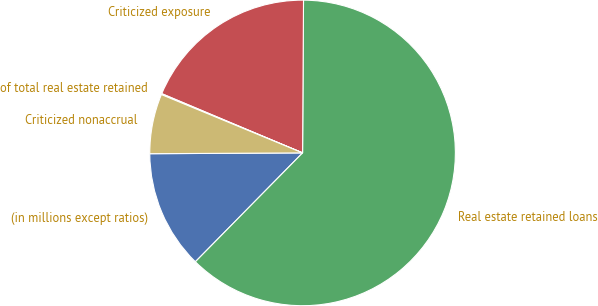Convert chart. <chart><loc_0><loc_0><loc_500><loc_500><pie_chart><fcel>(in millions except ratios)<fcel>Real estate retained loans<fcel>Criticized exposure<fcel>of total real estate retained<fcel>Criticized nonaccrual<nl><fcel>12.54%<fcel>62.28%<fcel>18.76%<fcel>0.1%<fcel>6.32%<nl></chart> 